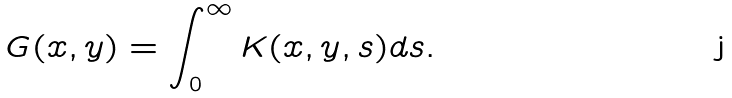<formula> <loc_0><loc_0><loc_500><loc_500>G ( x , y ) = \int _ { 0 } ^ { \infty } K ( x , y , s ) d s .</formula> 